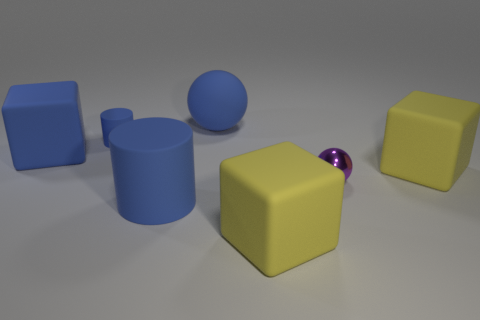Are there any small purple objects that have the same material as the large blue sphere?
Offer a very short reply. No. Is the metallic ball the same size as the blue ball?
Keep it short and to the point. No. How many cubes are rubber things or large blue rubber things?
Provide a succinct answer. 3. What material is the cube that is the same color as the matte sphere?
Offer a terse response. Rubber. What number of other metal objects have the same shape as the small purple object?
Offer a terse response. 0. Is the number of small purple objects that are on the right side of the purple ball greater than the number of yellow things that are right of the tiny blue rubber object?
Your answer should be compact. No. Does the large rubber thing that is in front of the big cylinder have the same color as the large rubber cylinder?
Offer a terse response. No. How big is the shiny object?
Offer a terse response. Small. There is a blue cylinder that is the same size as the purple metallic ball; what is its material?
Keep it short and to the point. Rubber. There is a small object to the left of the purple metallic thing; what is its color?
Give a very brief answer. Blue. 